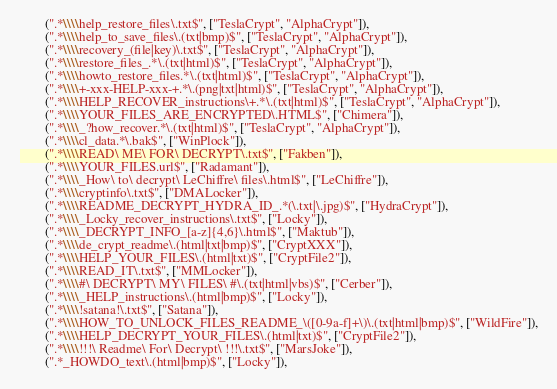<code> <loc_0><loc_0><loc_500><loc_500><_Python_>        (".*\\\\help_restore_files\.txt$", ["TeslaCrypt", "AlphaCrypt"]),
        (".*\\\\help_to_save_files\.(txt|bmp)$", ["TeslaCrypt", "AlphaCrypt"]),
        (".*\\\\recovery_(file|key)\.txt$", ["TeslaCrypt", "AlphaCrypt"]),
        (".*\\\\restore_files_.*\.(txt|html)$", ["TeslaCrypt", "AlphaCrypt"]),
        (".*\\\\howto_restore_files.*\.(txt|html)$", ["TeslaCrypt", "AlphaCrypt"]),
        (".*\\\\+-xxx-HELP-xxx-+.*\.(png|txt|html)$", ["TeslaCrypt", "AlphaCrypt"]),
        (".*\\\\HELP_RECOVER_instructions\+.*\.(txt|html)$", ["TeslaCrypt", "AlphaCrypt"]),
        (".*\\\\YOUR_FILES_ARE_ENCRYPTED\.HTML$", ["Chimera"]),
        (".*\\\\_?how_recover.*\.(txt|html)$", ["TeslaCrypt", "AlphaCrypt"]),
        (".*\\\\cl_data.*\.bak$", ["WinPlock"]),
        (".*\\\\READ\ ME\ FOR\ DECRYPT\.txt$", ["Fakben"]),
        (".*\\\\YOUR_FILES.url$", ["Radamant"]),
        (".*\\\\_How\ to\ decrypt\ LeChiffre\ files\.html$", ["LeChiffre"]),
        (".*\\\\cryptinfo\.txt$", ["DMALocker"]),
        (".*\\\\README_DECRYPT_HYDRA_ID_.*(\.txt|\.jpg)$", ["HydraCrypt"]),
        (".*\\\\_Locky_recover_instructions\.txt$", ["Locky"]),
        (".*\\\\_DECRYPT_INFO_[a-z]{4,6}\.html$", ["Maktub"]),
        (".*\\\\de_crypt_readme\.(html|txt|bmp)$", ["CryptXXX"]),
        (".*\\\\HELP_YOUR_FILES\.(html|txt)$", ["CryptFile2"]),
        (".*\\\\READ_IT\.txt$", ["MMLocker"]),
        (".*\\\\#\ DECRYPT\ MY\ FILES\ #\.(txt|html|vbs)$", ["Cerber"]),
        (".*\\\\_HELP_instructions\.(html|bmp)$", ["Locky"]),
        (".*\\\\!satana!\.txt$", ["Satana"]),
        (".*\\\\HOW_TO_UNLOCK_FILES_README_\([0-9a-f]+\)\.(txt|html|bmp)$", ["WildFire"]),
        (".*\\\\HELP_DECRYPT_YOUR_FILES\.(html|txt)$", ["CryptFile2"]),
        (".*\\\\!!!\ Readme\ For\ Decrypt\ !!!\.txt$", ["MarsJoke"]),
        (".*_HOWDO_text\.(html|bmp)$", ["Locky"]),</code> 